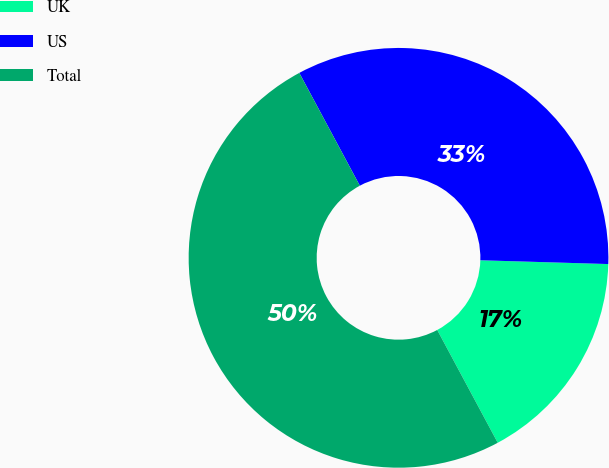Convert chart to OTSL. <chart><loc_0><loc_0><loc_500><loc_500><pie_chart><fcel>UK<fcel>US<fcel>Total<nl><fcel>16.69%<fcel>33.31%<fcel>50.0%<nl></chart> 